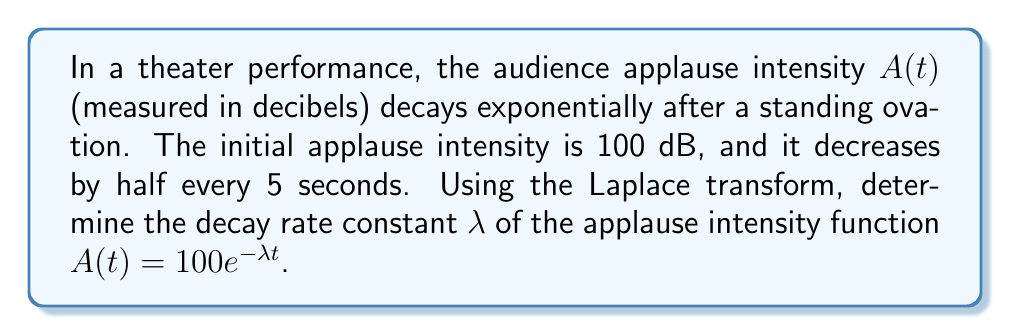Could you help me with this problem? Let's approach this step-by-step:

1) We're given that the applause intensity function is of the form:
   $$A(t) = 100e^{-\lambda t}$$

2) We know that the intensity halves every 5 seconds. This means:
   $$A(5) = \frac{1}{2}A(0)$$

3) Let's substitute these values:
   $$100e^{-5\lambda} = \frac{1}{2}(100)$$

4) Simplify:
   $$e^{-5\lambda} = \frac{1}{2}$$

5) Take the natural logarithm of both sides:
   $$-5\lambda = \ln(\frac{1}{2}) = -\ln(2)$$

6) Solve for $\lambda$:
   $$\lambda = \frac{\ln(2)}{5}$$

7) To use the Laplace transform, recall that for a function $f(t) = e^{at}$, its Laplace transform is:
   $$\mathcal{L}\{e^{at}\} = \frac{1}{s-a}$$

8) In our case, $a = -\lambda$, so the Laplace transform of $A(t)$ is:
   $$\mathcal{L}\{A(t)\} = \mathcal{L}\{100e^{-\lambda t}\} = \frac{100}{s+\lambda}$$

9) The pole of this Laplace transform is at $s = -\lambda$, which represents the decay rate of the function.
Answer: The decay rate constant $\lambda$ is $\frac{\ln(2)}{5} \approx 0.1386$ per second. 